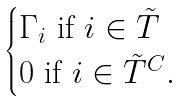Convert formula to latex. <formula><loc_0><loc_0><loc_500><loc_500>\begin{cases} \Gamma _ { i } \text { if } i \in \tilde { T } \\ 0 \text { if } i \in \tilde { T } ^ { C } . \end{cases}</formula> 